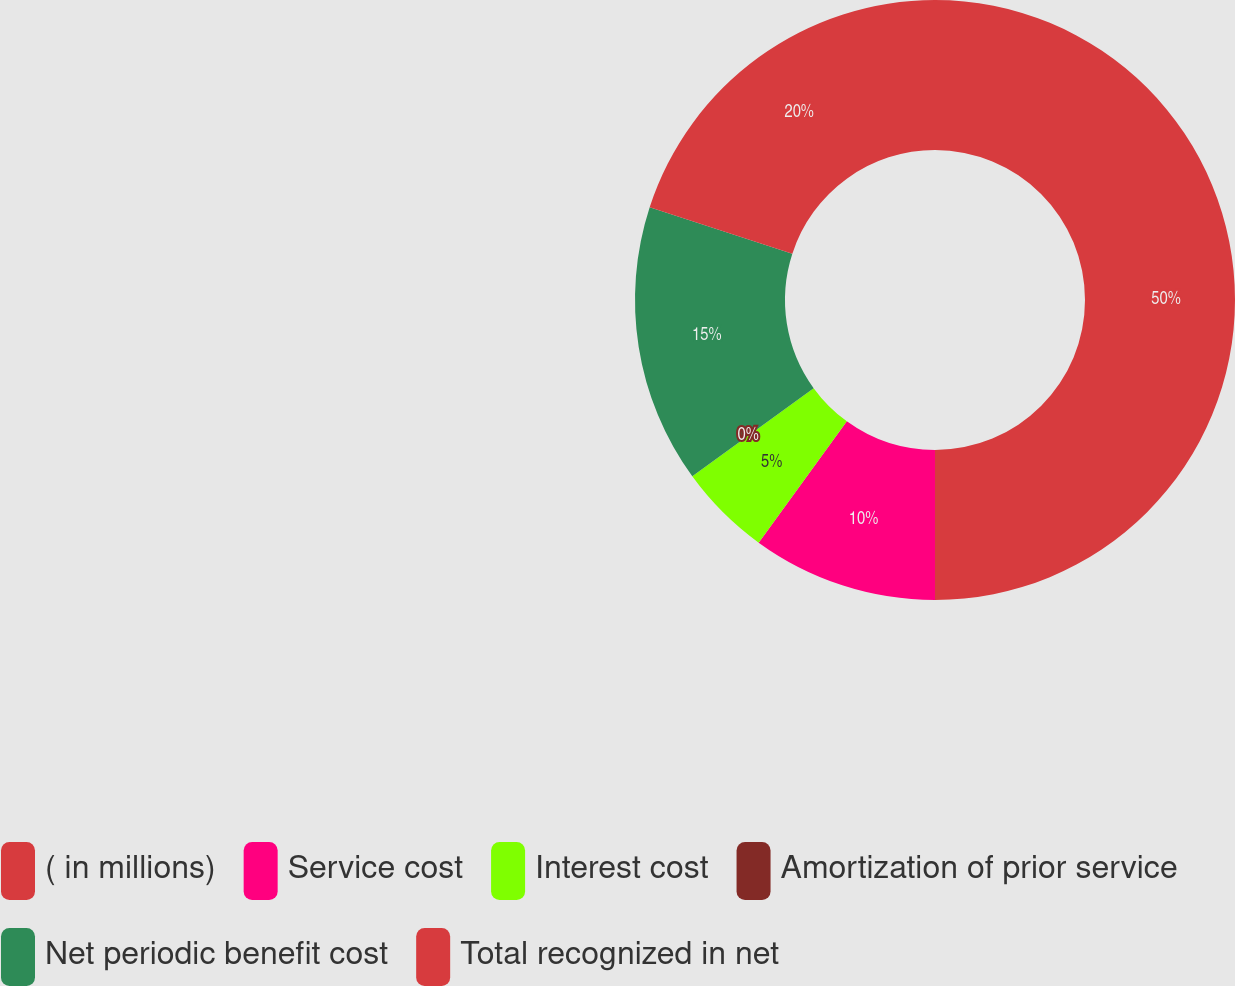<chart> <loc_0><loc_0><loc_500><loc_500><pie_chart><fcel>( in millions)<fcel>Service cost<fcel>Interest cost<fcel>Amortization of prior service<fcel>Net periodic benefit cost<fcel>Total recognized in net<nl><fcel>50.0%<fcel>10.0%<fcel>5.0%<fcel>0.0%<fcel>15.0%<fcel>20.0%<nl></chart> 